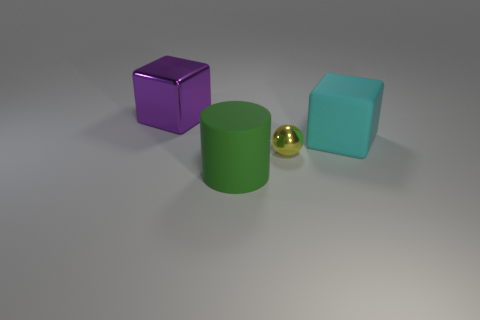Add 3 big cyan rubber cubes. How many objects exist? 7 Subtract all cyan cubes. How many cubes are left? 1 Subtract 1 cubes. How many cubes are left? 1 Add 1 large cyan rubber balls. How many large cyan rubber balls exist? 1 Subtract 0 gray blocks. How many objects are left? 4 Subtract all cylinders. How many objects are left? 3 Subtract all purple spheres. Subtract all cyan cylinders. How many spheres are left? 1 Subtract all gray balls. How many cyan blocks are left? 1 Subtract all large rubber cylinders. Subtract all yellow shiny spheres. How many objects are left? 2 Add 2 cylinders. How many cylinders are left? 3 